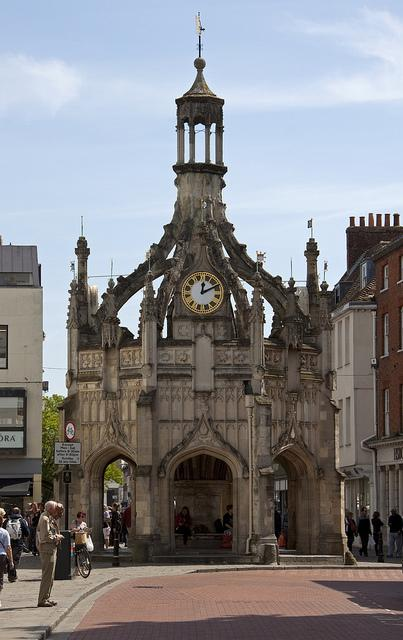Why would you look at this building? Please explain your reasoning. time. There is a clock on the front of it. 